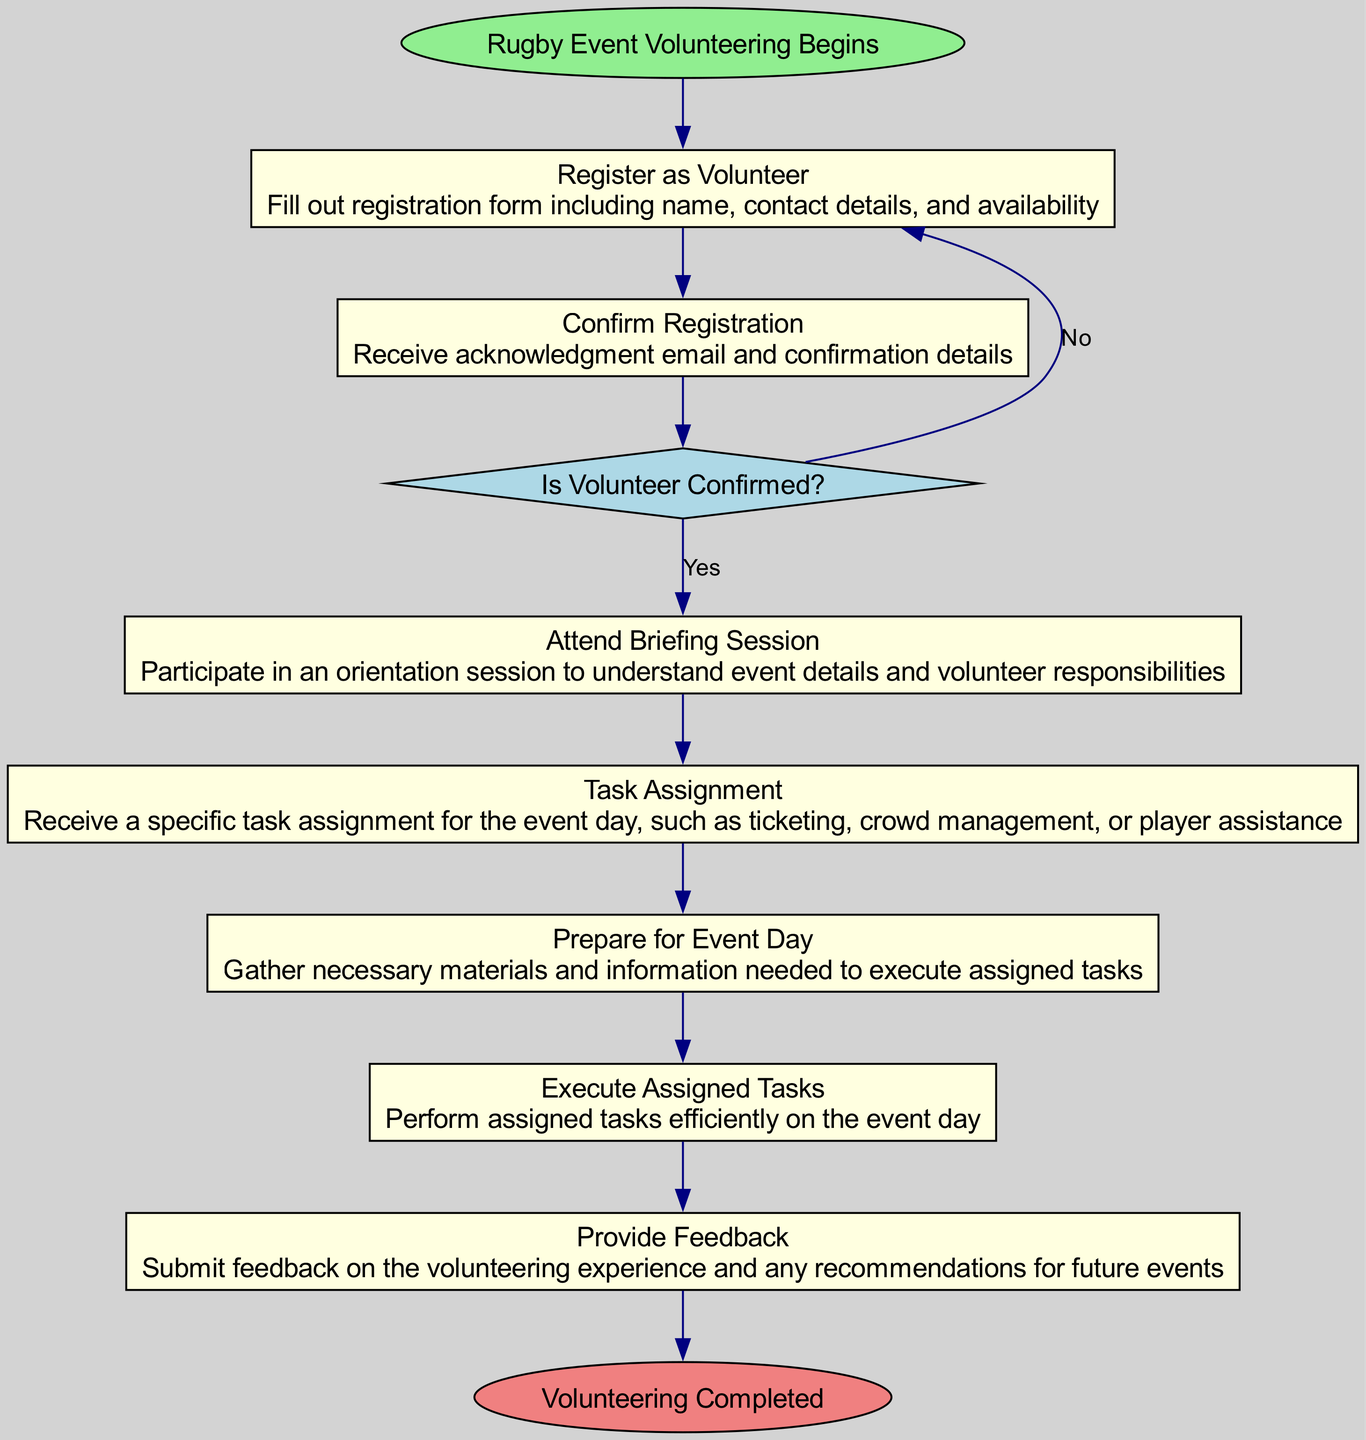What is the start event of the diagram? The start event, as indicated in the diagram, is "Rugby Event Volunteering Begins". It is the first node that initiates the flow of the activities.
Answer: Rugby Event Volunteering Begins How many activities are there in total? The diagram lists six activities, representing different steps in the volunteering process, starting from registration to providing feedback.
Answer: 6 What is the first activity listed? The first activity noted in the diagram is "Register as Volunteer." This is the initial task that volunteers must complete.
Answer: Register as Volunteer What happens if a volunteer is not confirmed? If a volunteer is not confirmed, the flow indicates that they should follow up on their registration status instead of moving forward to the briefing session.
Answer: Follow up on registration status What is the role of the decision point in the diagram? The decision point, named "Is Volunteer Confirmed?", determines whether the volunteer has received confirmation. It affects the flow, as it directs confirmed volunteers to the briefing session while non-confirmed ones go back to registration.
Answer: Determines volunteer's next step What is the last activity before the volunteering process is completed? The last activity in the diagram before reaching the end event is "Provide Feedback." This is the final step where volunteers can share their experiences.
Answer: Provide Feedback How is the connection between 'Confirm Registration' and 'Attend Briefing Session' established? The connection is established through the decision point “Is Volunteer Confirmed?”. If the confirmation is received, the flow proceeds to 'Attend Briefing Session'.
Answer: Through the decision point What does the end event signify in the diagram? The end event, "Volunteering Completed," signifies that all activities have been successfully performed and the volunteering process has concluded.
Answer: Volunteering Completed 